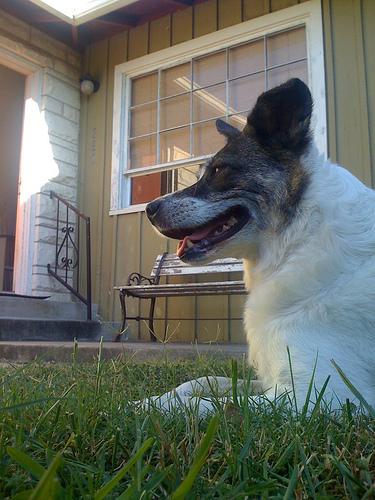Is this scene indoors?
Quick response, please. No. How many dogs are in this scene?
Quick response, please. 1. Is the window open?
Quick response, please. Yes. 